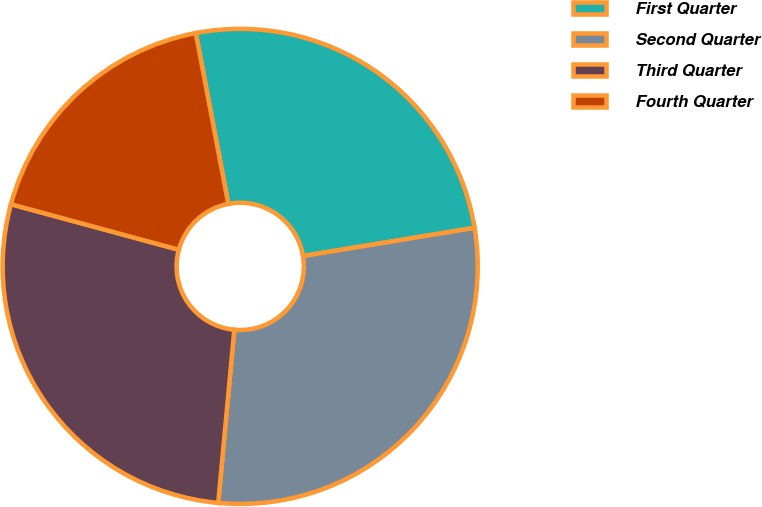<chart> <loc_0><loc_0><loc_500><loc_500><pie_chart><fcel>First Quarter<fcel>Second Quarter<fcel>Third Quarter<fcel>Fourth Quarter<nl><fcel>25.4%<fcel>29.07%<fcel>27.74%<fcel>17.79%<nl></chart> 